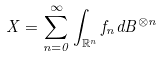<formula> <loc_0><loc_0><loc_500><loc_500>X = \sum _ { n = 0 } ^ { \infty } \int _ { \mathbb { R } ^ { n } } f _ { n } d B ^ { \otimes n }</formula> 